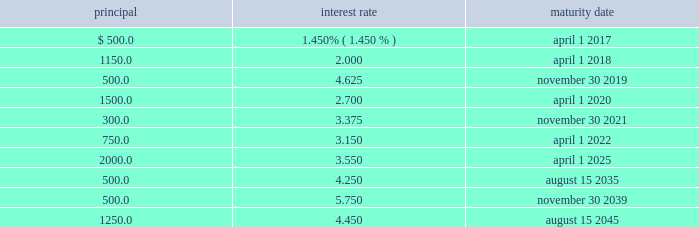Zimmer biomet holdings , inc .
2015 form 10-k annual report through february 25 , 2016 , we repurchased approximately $ 415.0 million of shares of our common stock , which includes the $ 250.0 million of shares that we repurchased from certain selling stockholders on february 10 , 2016 .
In order to achieve operational synergies , we expect cash outlays related to our integration plans to be approximately $ 290.0 million in 2016 .
These cash outlays are necessary to achieve our integration goals of net annual pre-tax operating profit synergies of $ 350.0 million by the end of the third year post-closing date .
Also as discussed in note 20 to our consolidated financial statements , as of december 31 , 2015 , a short-term liability of $ 50.0 million and long-term liability of $ 264.6 million related to durom cup product liability claims was recorded on our consolidated balance sheet .
We expect to continue paying these claims over the next few years .
We expect to be reimbursed a portion of these payments for product liability claims from insurance carriers .
As of december 31 , 2015 , we have received a portion of the insurance proceeds we estimate we will recover .
We have a long-term receivable of $ 95.3 million remaining for future expected reimbursements from our insurance carriers .
We also had a short-term liability of $ 33.4 million related to biomet metal-on-metal hip implant claims .
At december 31 , 2015 , we had ten tranches of senior notes outstanding as follows ( dollars in millions ) : principal interest rate maturity date .
We issued $ 7.65 billion of senior notes in march 2015 ( the 201cmerger notes 201d ) , the proceeds of which were used to finance a portion of the cash consideration payable in the biomet merger , pay merger related fees and expenses and pay a portion of biomet 2019s funded debt .
On june 24 , 2015 , we also borrowed $ 3.0 billion on a u.s .
Term loan ( 201cu.s .
Term loan 201d ) to fund the biomet merger .
We may , at our option , redeem our senior notes , in whole or in part , at any time upon payment of the principal , any applicable make-whole premium , and accrued and unpaid interest to the date of redemption .
In addition , the merger notes and the 3.375% ( 3.375 % ) senior notes due 2021 may be redeemed at our option without any make-whole premium at specified dates ranging from one month to six months in advance of the scheduled maturity date .
We have a $ 4.35 billion credit agreement ( 201ccredit agreement 201d ) that contains : ( i ) a 5-year unsecured u.s .
Term loan facility ( 201cu.s .
Term loan facility 201d ) in the principal amount of $ 3.0 billion , and ( ii ) a 5-year unsecured multicurrency revolving facility ( 201cmulticurrency revolving facility 201d ) in the principal amount of $ 1.35 billion .
The multicurrency revolving facility will mature in may 2019 , with two one-year extensions available at our option .
Borrowings under the multicurrency revolving facility may be used for general corporate purposes .
There were no borrowings outstanding under the multicurrency revolving facility as of december 31 , 2015 .
The u.s .
Term loan facility will mature in june 2020 , with principal payments due beginning september 30 , 2015 , as follows : $ 75.0 million on a quarterly basis during the first three years , $ 112.5 million on a quarterly basis during the fourth year , and $ 412.5 million on a quarterly basis during the fifth year .
In 2015 , we paid $ 500.0 million in principal under the u.s .
Term loan facility , resulting in $ 2.5 billion in outstanding borrowings as of december 31 , we and certain of our wholly owned foreign subsidiaries are the borrowers under the credit agreement .
Borrowings under the credit agreement bear interest at floating rates based upon indices determined by the currency of the borrowings plus an applicable margin determined by reference to our senior unsecured long-term credit rating , or at an alternate base rate , or , in the case of borrowings under the multicurrency revolving facility only , at a fixed rate determined through a competitive bid process .
The credit agreement contains customary affirmative and negative covenants and events of default for an unsecured financing arrangement , including , among other things , limitations on consolidations , mergers and sales of assets .
Financial covenants include a consolidated indebtedness to consolidated ebitda ratio of no greater than 5.0 to 1.0 through june 24 , 2016 and no greater than 4.5 to 1.0 thereafter .
If our credit rating falls below investment grade , additional restrictions would result , including restrictions on investments and payment of dividends .
We were in compliance with all covenants under the credit agreement as of december 31 , 2015 .
Commitments under the credit agreement are subject to certain fees .
On the multicurrency revolving facility , we pay a facility fee at a rate determined by reference to our senior unsecured long-term credit rating .
We have a japan term loan agreement with one of the lenders under the credit agreement for 11.7 billion japanese yen that will mature on may 31 , 2018 .
Borrowings under the japan term loan bear interest at a fixed rate of 0.61 percent per annum until maturity .
We also have other available uncommitted credit facilities totaling $ 35.8 million .
We place our cash and cash equivalents in highly-rated financial institutions and limit the amount of credit exposure to any one entity .
We invest only in high-quality financial instruments in accordance with our internal investment policy .
As of december 31 , 2015 , we had short-term and long-term investments in debt securities with a fair value of $ 273.1 million .
These investments are in debt securities of many different issuers and , therefore , we believe we have no significant concentration of risk with a single issuer .
All of these debt securities remain highly rated and we believe the risk of default by the issuers is low. .
What is the short-term liability of $ 33.4 million related to biomet metal-on-metal hip implant claims as a percentage of the long-term receivable of $ 95.3 million remaining for future expected reimbursements from our insurance carriers? 
Computations: (33.4 / 95.3)
Answer: 0.35047. 